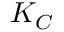<formula> <loc_0><loc_0><loc_500><loc_500>K _ { C }</formula> 